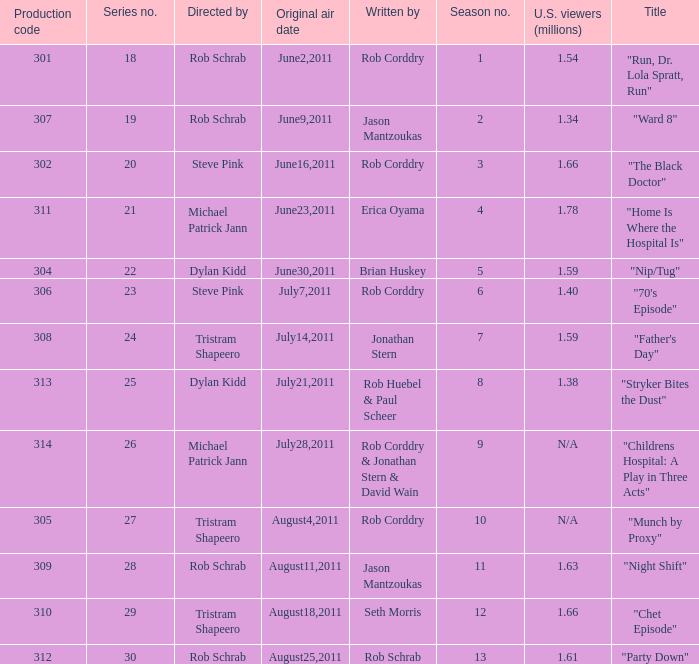Who directed the episode entitled "home is where the hospital is"? Michael Patrick Jann. 